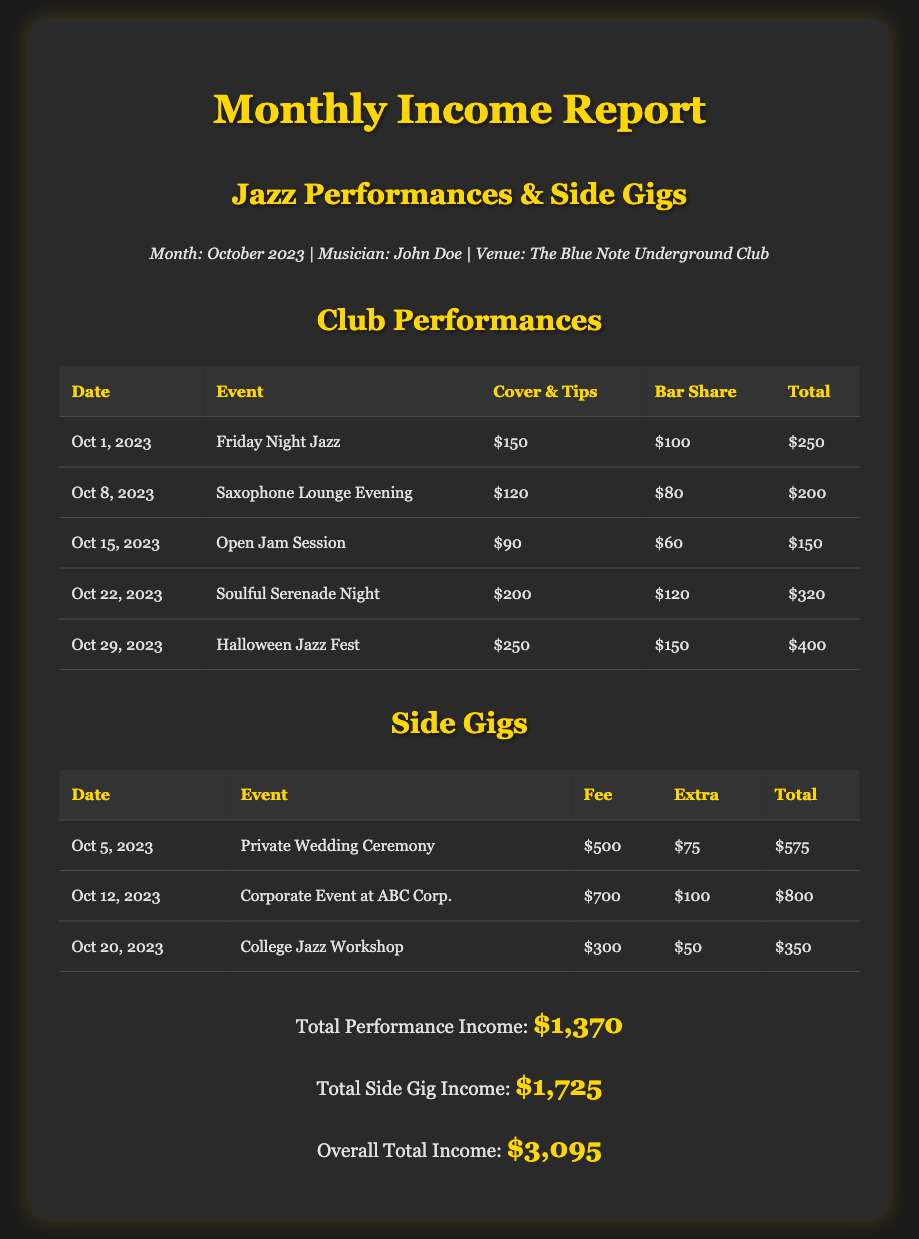What is the month of the report? The month of the report is specified at the beginning of the document.
Answer: October 2023 Who is the musician mentioned in the report? The musician's name is explicitly stated in the introductory section of the document.
Answer: John Doe How much was earned from the Halloween Jazz Fest? The total from the Halloween Jazz Fest is detailed in the Club Performances table.
Answer: $400 What was the total income from side gigs? The total income from side gigs is listed in the summary section of the document.
Answer: $1,725 Which club event occurred on October 22, 2023? The specific event that took place on that date is provided in the table.
Answer: Soulful Serenade Night What is the overall total income reported? The overall total income is presented in the summary section, calculated from all income sources.
Answer: $3,095 What was the fee for the corporate event at ABC Corp.? The fee for that particular side gig is detailed in the corresponding table.
Answer: $700 What is the total from club performances? The total from club performances can be inferred from the summary section through the addition of each club performance total.
Answer: $1,370 On what date was the Private Wedding Ceremony gig? The date for that specific event is included in the side gigs table.
Answer: October 5, 2023 